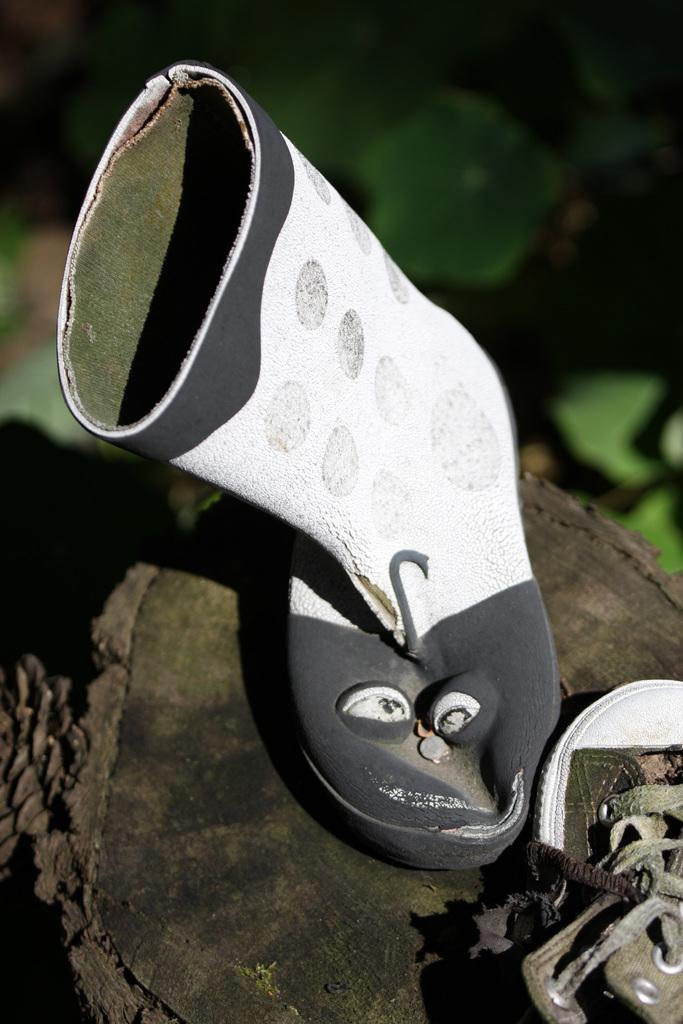What is placed on the trunk of the tree in the image? There are shoes on the trunk of a tree. Can you describe the background of the image? The background is blurred, and there is greenery visible. Where is the error in the image? There is no error present in the image. What type of gun can be seen in the image? There is no gun present in the image. 